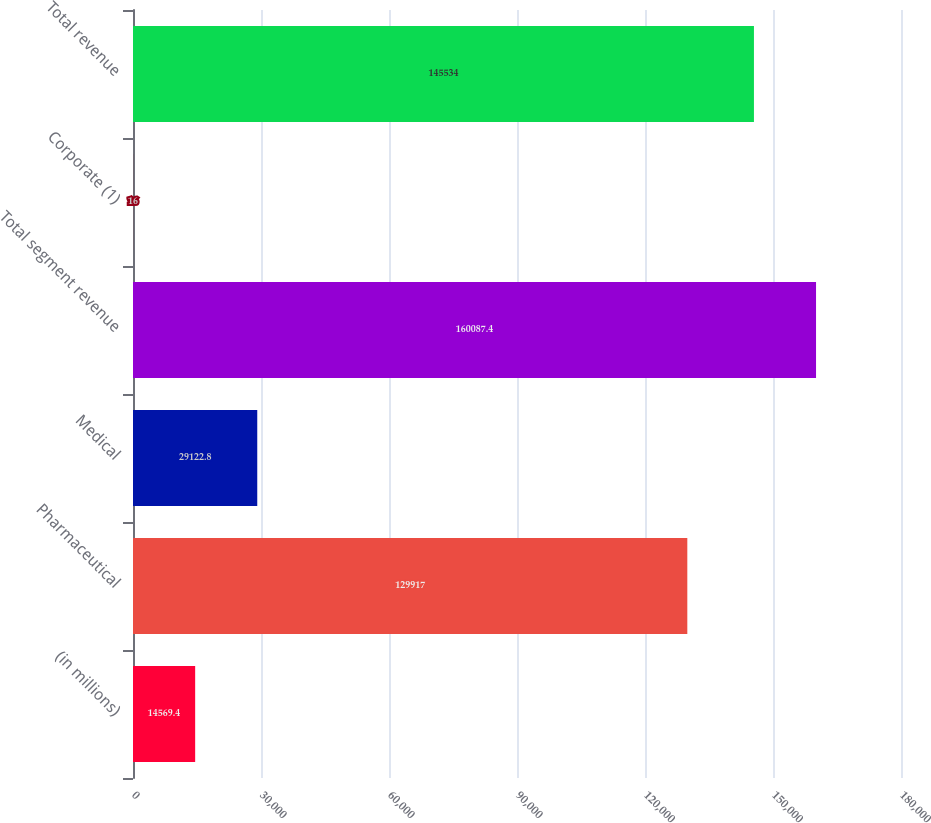Convert chart. <chart><loc_0><loc_0><loc_500><loc_500><bar_chart><fcel>(in millions)<fcel>Pharmaceutical<fcel>Medical<fcel>Total segment revenue<fcel>Corporate (1)<fcel>Total revenue<nl><fcel>14569.4<fcel>129917<fcel>29122.8<fcel>160087<fcel>16<fcel>145534<nl></chart> 